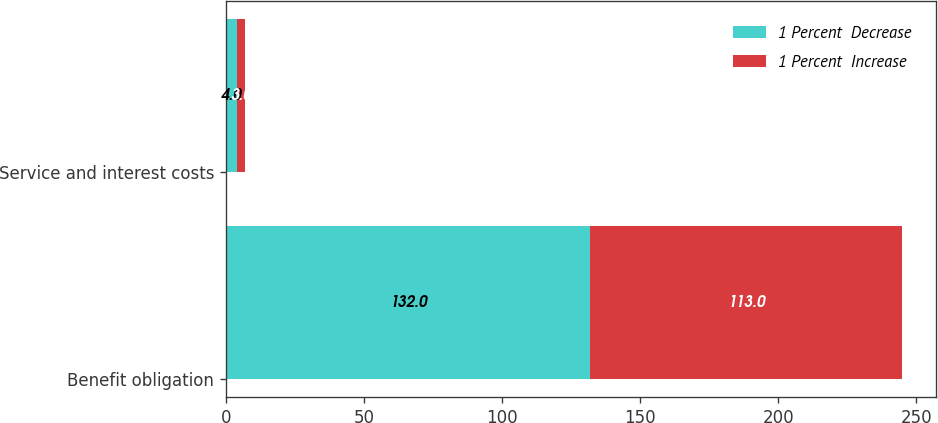Convert chart to OTSL. <chart><loc_0><loc_0><loc_500><loc_500><stacked_bar_chart><ecel><fcel>Benefit obligation<fcel>Service and interest costs<nl><fcel>1 Percent  Decrease<fcel>132<fcel>4<nl><fcel>1 Percent  Increase<fcel>113<fcel>3<nl></chart> 